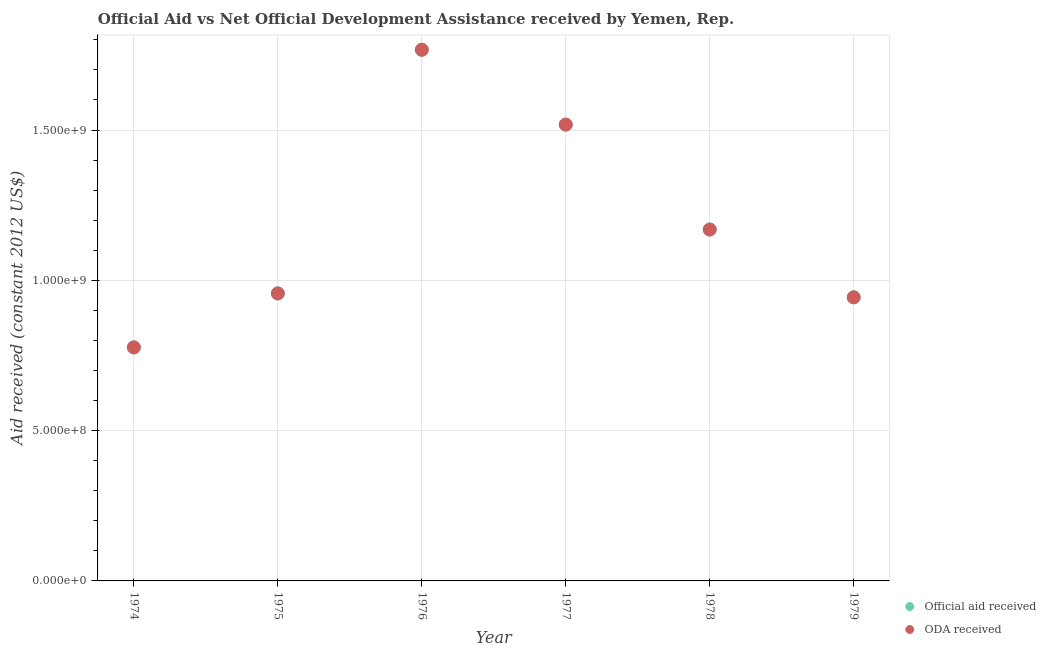How many different coloured dotlines are there?
Your response must be concise. 2. What is the official aid received in 1974?
Your response must be concise. 7.77e+08. Across all years, what is the maximum oda received?
Your answer should be compact. 1.77e+09. Across all years, what is the minimum oda received?
Provide a short and direct response. 7.77e+08. In which year was the oda received maximum?
Offer a very short reply. 1976. In which year was the oda received minimum?
Your response must be concise. 1974. What is the total official aid received in the graph?
Offer a very short reply. 7.13e+09. What is the difference between the oda received in 1976 and that in 1979?
Ensure brevity in your answer.  8.24e+08. What is the difference between the official aid received in 1975 and the oda received in 1976?
Provide a short and direct response. -8.11e+08. What is the average oda received per year?
Offer a terse response. 1.19e+09. In the year 1978, what is the difference between the official aid received and oda received?
Offer a very short reply. 0. In how many years, is the oda received greater than 200000000 US$?
Your answer should be compact. 6. What is the ratio of the oda received in 1976 to that in 1978?
Keep it short and to the point. 1.51. What is the difference between the highest and the second highest official aid received?
Give a very brief answer. 2.49e+08. What is the difference between the highest and the lowest official aid received?
Offer a terse response. 9.90e+08. Is the official aid received strictly greater than the oda received over the years?
Make the answer very short. No. Is the oda received strictly less than the official aid received over the years?
Give a very brief answer. No. How many dotlines are there?
Make the answer very short. 2. Are the values on the major ticks of Y-axis written in scientific E-notation?
Give a very brief answer. Yes. Does the graph contain any zero values?
Keep it short and to the point. No. Does the graph contain grids?
Ensure brevity in your answer.  Yes. What is the title of the graph?
Offer a terse response. Official Aid vs Net Official Development Assistance received by Yemen, Rep. . What is the label or title of the Y-axis?
Give a very brief answer. Aid received (constant 2012 US$). What is the Aid received (constant 2012 US$) in Official aid received in 1974?
Your answer should be compact. 7.77e+08. What is the Aid received (constant 2012 US$) in ODA received in 1974?
Offer a terse response. 7.77e+08. What is the Aid received (constant 2012 US$) in Official aid received in 1975?
Ensure brevity in your answer.  9.56e+08. What is the Aid received (constant 2012 US$) of ODA received in 1975?
Keep it short and to the point. 9.56e+08. What is the Aid received (constant 2012 US$) of Official aid received in 1976?
Offer a very short reply. 1.77e+09. What is the Aid received (constant 2012 US$) in ODA received in 1976?
Make the answer very short. 1.77e+09. What is the Aid received (constant 2012 US$) in Official aid received in 1977?
Provide a succinct answer. 1.52e+09. What is the Aid received (constant 2012 US$) of ODA received in 1977?
Provide a short and direct response. 1.52e+09. What is the Aid received (constant 2012 US$) in Official aid received in 1978?
Your answer should be very brief. 1.17e+09. What is the Aid received (constant 2012 US$) of ODA received in 1978?
Give a very brief answer. 1.17e+09. What is the Aid received (constant 2012 US$) of Official aid received in 1979?
Your answer should be compact. 9.43e+08. What is the Aid received (constant 2012 US$) in ODA received in 1979?
Provide a succinct answer. 9.43e+08. Across all years, what is the maximum Aid received (constant 2012 US$) of Official aid received?
Provide a short and direct response. 1.77e+09. Across all years, what is the maximum Aid received (constant 2012 US$) of ODA received?
Offer a very short reply. 1.77e+09. Across all years, what is the minimum Aid received (constant 2012 US$) in Official aid received?
Ensure brevity in your answer.  7.77e+08. Across all years, what is the minimum Aid received (constant 2012 US$) of ODA received?
Provide a short and direct response. 7.77e+08. What is the total Aid received (constant 2012 US$) of Official aid received in the graph?
Offer a terse response. 7.13e+09. What is the total Aid received (constant 2012 US$) in ODA received in the graph?
Your response must be concise. 7.13e+09. What is the difference between the Aid received (constant 2012 US$) of Official aid received in 1974 and that in 1975?
Offer a terse response. -1.80e+08. What is the difference between the Aid received (constant 2012 US$) in ODA received in 1974 and that in 1975?
Make the answer very short. -1.80e+08. What is the difference between the Aid received (constant 2012 US$) in Official aid received in 1974 and that in 1976?
Provide a short and direct response. -9.90e+08. What is the difference between the Aid received (constant 2012 US$) of ODA received in 1974 and that in 1976?
Offer a very short reply. -9.90e+08. What is the difference between the Aid received (constant 2012 US$) in Official aid received in 1974 and that in 1977?
Your response must be concise. -7.41e+08. What is the difference between the Aid received (constant 2012 US$) of ODA received in 1974 and that in 1977?
Your answer should be very brief. -7.41e+08. What is the difference between the Aid received (constant 2012 US$) in Official aid received in 1974 and that in 1978?
Provide a succinct answer. -3.92e+08. What is the difference between the Aid received (constant 2012 US$) of ODA received in 1974 and that in 1978?
Your response must be concise. -3.92e+08. What is the difference between the Aid received (constant 2012 US$) in Official aid received in 1974 and that in 1979?
Keep it short and to the point. -1.67e+08. What is the difference between the Aid received (constant 2012 US$) in ODA received in 1974 and that in 1979?
Give a very brief answer. -1.67e+08. What is the difference between the Aid received (constant 2012 US$) in Official aid received in 1975 and that in 1976?
Provide a succinct answer. -8.11e+08. What is the difference between the Aid received (constant 2012 US$) in ODA received in 1975 and that in 1976?
Your answer should be compact. -8.11e+08. What is the difference between the Aid received (constant 2012 US$) of Official aid received in 1975 and that in 1977?
Offer a very short reply. -5.62e+08. What is the difference between the Aid received (constant 2012 US$) in ODA received in 1975 and that in 1977?
Your response must be concise. -5.62e+08. What is the difference between the Aid received (constant 2012 US$) of Official aid received in 1975 and that in 1978?
Your response must be concise. -2.13e+08. What is the difference between the Aid received (constant 2012 US$) of ODA received in 1975 and that in 1978?
Offer a very short reply. -2.13e+08. What is the difference between the Aid received (constant 2012 US$) of Official aid received in 1975 and that in 1979?
Your answer should be compact. 1.30e+07. What is the difference between the Aid received (constant 2012 US$) in ODA received in 1975 and that in 1979?
Offer a terse response. 1.30e+07. What is the difference between the Aid received (constant 2012 US$) of Official aid received in 1976 and that in 1977?
Offer a very short reply. 2.49e+08. What is the difference between the Aid received (constant 2012 US$) in ODA received in 1976 and that in 1977?
Make the answer very short. 2.49e+08. What is the difference between the Aid received (constant 2012 US$) of Official aid received in 1976 and that in 1978?
Keep it short and to the point. 5.98e+08. What is the difference between the Aid received (constant 2012 US$) in ODA received in 1976 and that in 1978?
Ensure brevity in your answer.  5.98e+08. What is the difference between the Aid received (constant 2012 US$) in Official aid received in 1976 and that in 1979?
Give a very brief answer. 8.24e+08. What is the difference between the Aid received (constant 2012 US$) of ODA received in 1976 and that in 1979?
Provide a short and direct response. 8.24e+08. What is the difference between the Aid received (constant 2012 US$) in Official aid received in 1977 and that in 1978?
Offer a terse response. 3.49e+08. What is the difference between the Aid received (constant 2012 US$) in ODA received in 1977 and that in 1978?
Offer a terse response. 3.49e+08. What is the difference between the Aid received (constant 2012 US$) in Official aid received in 1977 and that in 1979?
Offer a terse response. 5.75e+08. What is the difference between the Aid received (constant 2012 US$) of ODA received in 1977 and that in 1979?
Ensure brevity in your answer.  5.75e+08. What is the difference between the Aid received (constant 2012 US$) of Official aid received in 1978 and that in 1979?
Ensure brevity in your answer.  2.26e+08. What is the difference between the Aid received (constant 2012 US$) of ODA received in 1978 and that in 1979?
Give a very brief answer. 2.26e+08. What is the difference between the Aid received (constant 2012 US$) in Official aid received in 1974 and the Aid received (constant 2012 US$) in ODA received in 1975?
Your answer should be very brief. -1.80e+08. What is the difference between the Aid received (constant 2012 US$) in Official aid received in 1974 and the Aid received (constant 2012 US$) in ODA received in 1976?
Keep it short and to the point. -9.90e+08. What is the difference between the Aid received (constant 2012 US$) of Official aid received in 1974 and the Aid received (constant 2012 US$) of ODA received in 1977?
Offer a very short reply. -7.41e+08. What is the difference between the Aid received (constant 2012 US$) in Official aid received in 1974 and the Aid received (constant 2012 US$) in ODA received in 1978?
Your response must be concise. -3.92e+08. What is the difference between the Aid received (constant 2012 US$) of Official aid received in 1974 and the Aid received (constant 2012 US$) of ODA received in 1979?
Your response must be concise. -1.67e+08. What is the difference between the Aid received (constant 2012 US$) in Official aid received in 1975 and the Aid received (constant 2012 US$) in ODA received in 1976?
Offer a terse response. -8.11e+08. What is the difference between the Aid received (constant 2012 US$) in Official aid received in 1975 and the Aid received (constant 2012 US$) in ODA received in 1977?
Your answer should be very brief. -5.62e+08. What is the difference between the Aid received (constant 2012 US$) of Official aid received in 1975 and the Aid received (constant 2012 US$) of ODA received in 1978?
Keep it short and to the point. -2.13e+08. What is the difference between the Aid received (constant 2012 US$) in Official aid received in 1975 and the Aid received (constant 2012 US$) in ODA received in 1979?
Keep it short and to the point. 1.30e+07. What is the difference between the Aid received (constant 2012 US$) in Official aid received in 1976 and the Aid received (constant 2012 US$) in ODA received in 1977?
Provide a succinct answer. 2.49e+08. What is the difference between the Aid received (constant 2012 US$) of Official aid received in 1976 and the Aid received (constant 2012 US$) of ODA received in 1978?
Offer a terse response. 5.98e+08. What is the difference between the Aid received (constant 2012 US$) of Official aid received in 1976 and the Aid received (constant 2012 US$) of ODA received in 1979?
Offer a very short reply. 8.24e+08. What is the difference between the Aid received (constant 2012 US$) in Official aid received in 1977 and the Aid received (constant 2012 US$) in ODA received in 1978?
Offer a terse response. 3.49e+08. What is the difference between the Aid received (constant 2012 US$) of Official aid received in 1977 and the Aid received (constant 2012 US$) of ODA received in 1979?
Give a very brief answer. 5.75e+08. What is the difference between the Aid received (constant 2012 US$) in Official aid received in 1978 and the Aid received (constant 2012 US$) in ODA received in 1979?
Give a very brief answer. 2.26e+08. What is the average Aid received (constant 2012 US$) of Official aid received per year?
Your answer should be very brief. 1.19e+09. What is the average Aid received (constant 2012 US$) in ODA received per year?
Your response must be concise. 1.19e+09. In the year 1974, what is the difference between the Aid received (constant 2012 US$) in Official aid received and Aid received (constant 2012 US$) in ODA received?
Offer a very short reply. 0. In the year 1975, what is the difference between the Aid received (constant 2012 US$) of Official aid received and Aid received (constant 2012 US$) of ODA received?
Make the answer very short. 0. In the year 1978, what is the difference between the Aid received (constant 2012 US$) of Official aid received and Aid received (constant 2012 US$) of ODA received?
Your response must be concise. 0. In the year 1979, what is the difference between the Aid received (constant 2012 US$) of Official aid received and Aid received (constant 2012 US$) of ODA received?
Ensure brevity in your answer.  0. What is the ratio of the Aid received (constant 2012 US$) in Official aid received in 1974 to that in 1975?
Your answer should be compact. 0.81. What is the ratio of the Aid received (constant 2012 US$) of ODA received in 1974 to that in 1975?
Provide a succinct answer. 0.81. What is the ratio of the Aid received (constant 2012 US$) of Official aid received in 1974 to that in 1976?
Your response must be concise. 0.44. What is the ratio of the Aid received (constant 2012 US$) of ODA received in 1974 to that in 1976?
Keep it short and to the point. 0.44. What is the ratio of the Aid received (constant 2012 US$) in Official aid received in 1974 to that in 1977?
Give a very brief answer. 0.51. What is the ratio of the Aid received (constant 2012 US$) in ODA received in 1974 to that in 1977?
Provide a short and direct response. 0.51. What is the ratio of the Aid received (constant 2012 US$) of Official aid received in 1974 to that in 1978?
Give a very brief answer. 0.66. What is the ratio of the Aid received (constant 2012 US$) of ODA received in 1974 to that in 1978?
Offer a terse response. 0.66. What is the ratio of the Aid received (constant 2012 US$) of Official aid received in 1974 to that in 1979?
Keep it short and to the point. 0.82. What is the ratio of the Aid received (constant 2012 US$) in ODA received in 1974 to that in 1979?
Offer a terse response. 0.82. What is the ratio of the Aid received (constant 2012 US$) of Official aid received in 1975 to that in 1976?
Provide a short and direct response. 0.54. What is the ratio of the Aid received (constant 2012 US$) in ODA received in 1975 to that in 1976?
Offer a terse response. 0.54. What is the ratio of the Aid received (constant 2012 US$) of Official aid received in 1975 to that in 1977?
Give a very brief answer. 0.63. What is the ratio of the Aid received (constant 2012 US$) of ODA received in 1975 to that in 1977?
Your answer should be very brief. 0.63. What is the ratio of the Aid received (constant 2012 US$) of Official aid received in 1975 to that in 1978?
Ensure brevity in your answer.  0.82. What is the ratio of the Aid received (constant 2012 US$) in ODA received in 1975 to that in 1978?
Ensure brevity in your answer.  0.82. What is the ratio of the Aid received (constant 2012 US$) of Official aid received in 1975 to that in 1979?
Make the answer very short. 1.01. What is the ratio of the Aid received (constant 2012 US$) of ODA received in 1975 to that in 1979?
Your response must be concise. 1.01. What is the ratio of the Aid received (constant 2012 US$) in Official aid received in 1976 to that in 1977?
Offer a terse response. 1.16. What is the ratio of the Aid received (constant 2012 US$) of ODA received in 1976 to that in 1977?
Your answer should be compact. 1.16. What is the ratio of the Aid received (constant 2012 US$) in Official aid received in 1976 to that in 1978?
Offer a very short reply. 1.51. What is the ratio of the Aid received (constant 2012 US$) of ODA received in 1976 to that in 1978?
Give a very brief answer. 1.51. What is the ratio of the Aid received (constant 2012 US$) of Official aid received in 1976 to that in 1979?
Keep it short and to the point. 1.87. What is the ratio of the Aid received (constant 2012 US$) of ODA received in 1976 to that in 1979?
Make the answer very short. 1.87. What is the ratio of the Aid received (constant 2012 US$) in Official aid received in 1977 to that in 1978?
Offer a very short reply. 1.3. What is the ratio of the Aid received (constant 2012 US$) of ODA received in 1977 to that in 1978?
Your response must be concise. 1.3. What is the ratio of the Aid received (constant 2012 US$) in Official aid received in 1977 to that in 1979?
Give a very brief answer. 1.61. What is the ratio of the Aid received (constant 2012 US$) in ODA received in 1977 to that in 1979?
Ensure brevity in your answer.  1.61. What is the ratio of the Aid received (constant 2012 US$) of Official aid received in 1978 to that in 1979?
Offer a very short reply. 1.24. What is the ratio of the Aid received (constant 2012 US$) of ODA received in 1978 to that in 1979?
Offer a very short reply. 1.24. What is the difference between the highest and the second highest Aid received (constant 2012 US$) of Official aid received?
Your response must be concise. 2.49e+08. What is the difference between the highest and the second highest Aid received (constant 2012 US$) in ODA received?
Offer a terse response. 2.49e+08. What is the difference between the highest and the lowest Aid received (constant 2012 US$) of Official aid received?
Make the answer very short. 9.90e+08. What is the difference between the highest and the lowest Aid received (constant 2012 US$) in ODA received?
Your response must be concise. 9.90e+08. 